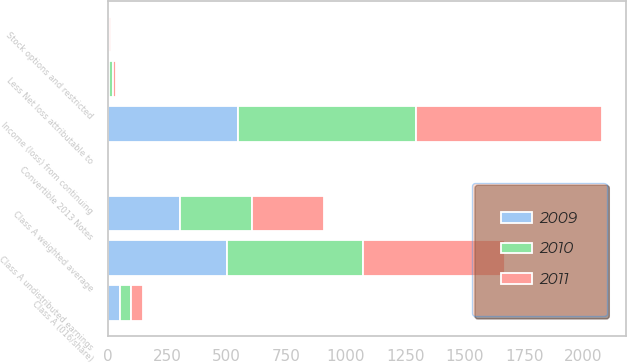Convert chart to OTSL. <chart><loc_0><loc_0><loc_500><loc_500><stacked_bar_chart><ecel><fcel>Income (loss) from continuing<fcel>Less Net loss attributable to<fcel>Class A (016/share)<fcel>Class A undistributed earnings<fcel>Class A weighted average<fcel>Stock options and restricted<fcel>Convertible 2013 Notes<nl><fcel>2010<fcel>750<fcel>17<fcel>49<fcel>572<fcel>303<fcel>6<fcel>1<nl><fcel>2011<fcel>780<fcel>15<fcel>49<fcel>597<fcel>303<fcel>6<fcel>0<nl><fcel>2009<fcel>546<fcel>4<fcel>50<fcel>501<fcel>302<fcel>0<fcel>0<nl></chart> 